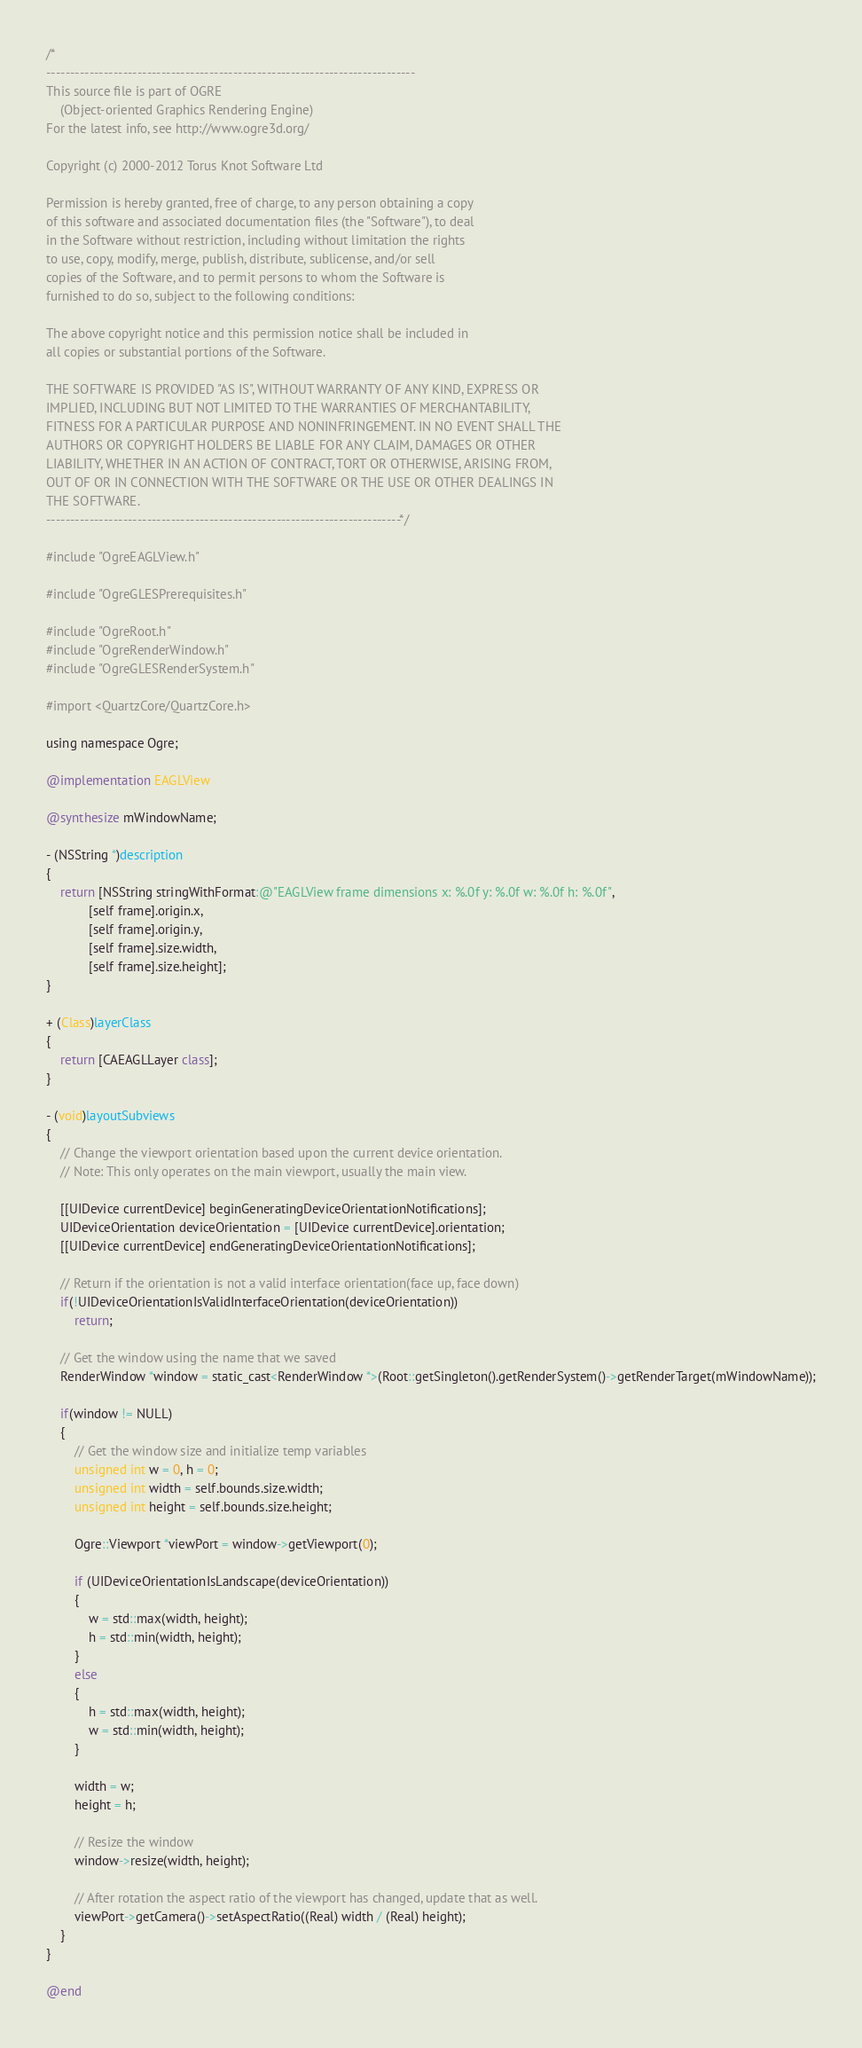<code> <loc_0><loc_0><loc_500><loc_500><_ObjectiveC_>/*
-----------------------------------------------------------------------------
This source file is part of OGRE
    (Object-oriented Graphics Rendering Engine)
For the latest info, see http://www.ogre3d.org/

Copyright (c) 2000-2012 Torus Knot Software Ltd

Permission is hereby granted, free of charge, to any person obtaining a copy
of this software and associated documentation files (the "Software"), to deal
in the Software without restriction, including without limitation the rights
to use, copy, modify, merge, publish, distribute, sublicense, and/or sell
copies of the Software, and to permit persons to whom the Software is
furnished to do so, subject to the following conditions:

The above copyright notice and this permission notice shall be included in
all copies or substantial portions of the Software.

THE SOFTWARE IS PROVIDED "AS IS", WITHOUT WARRANTY OF ANY KIND, EXPRESS OR
IMPLIED, INCLUDING BUT NOT LIMITED TO THE WARRANTIES OF MERCHANTABILITY,
FITNESS FOR A PARTICULAR PURPOSE AND NONINFRINGEMENT. IN NO EVENT SHALL THE
AUTHORS OR COPYRIGHT HOLDERS BE LIABLE FOR ANY CLAIM, DAMAGES OR OTHER
LIABILITY, WHETHER IN AN ACTION OF CONTRACT, TORT OR OTHERWISE, ARISING FROM,
OUT OF OR IN CONNECTION WITH THE SOFTWARE OR THE USE OR OTHER DEALINGS IN
THE SOFTWARE.
--------------------------------------------------------------------------*/

#include "OgreEAGLView.h"

#include "OgreGLESPrerequisites.h"

#include "OgreRoot.h"
#include "OgreRenderWindow.h"
#include "OgreGLESRenderSystem.h"

#import <QuartzCore/QuartzCore.h>

using namespace Ogre;

@implementation EAGLView

@synthesize mWindowName;

- (NSString *)description
{
    return [NSString stringWithFormat:@"EAGLView frame dimensions x: %.0f y: %.0f w: %.0f h: %.0f", 
            [self frame].origin.x,
            [self frame].origin.y,
            [self frame].size.width,
            [self frame].size.height];
}

+ (Class)layerClass
{
    return [CAEAGLLayer class];
}

- (void)layoutSubviews
{
    // Change the viewport orientation based upon the current device orientation.
    // Note: This only operates on the main viewport, usually the main view.

    [[UIDevice currentDevice] beginGeneratingDeviceOrientationNotifications];
    UIDeviceOrientation deviceOrientation = [UIDevice currentDevice].orientation;
    [[UIDevice currentDevice] endGeneratingDeviceOrientationNotifications];

    // Return if the orientation is not a valid interface orientation(face up, face down)
    if(!UIDeviceOrientationIsValidInterfaceOrientation(deviceOrientation))
        return;

    // Get the window using the name that we saved
    RenderWindow *window = static_cast<RenderWindow *>(Root::getSingleton().getRenderSystem()->getRenderTarget(mWindowName));

    if(window != NULL)
    {
        // Get the window size and initialize temp variables
        unsigned int w = 0, h = 0;
        unsigned int width = self.bounds.size.width;
        unsigned int height = self.bounds.size.height;

        Ogre::Viewport *viewPort = window->getViewport(0);

        if (UIDeviceOrientationIsLandscape(deviceOrientation))
        {
            w = std::max(width, height);
            h = std::min(width, height);
        }
        else
        {
            h = std::max(width, height);
            w = std::min(width, height);
        }

        width = w;
        height = h;

        // Resize the window
        window->resize(width, height);

        // After rotation the aspect ratio of the viewport has changed, update that as well.
        viewPort->getCamera()->setAspectRatio((Real) width / (Real) height);
    }
}

@end
</code> 